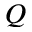<formula> <loc_0><loc_0><loc_500><loc_500>Q</formula> 